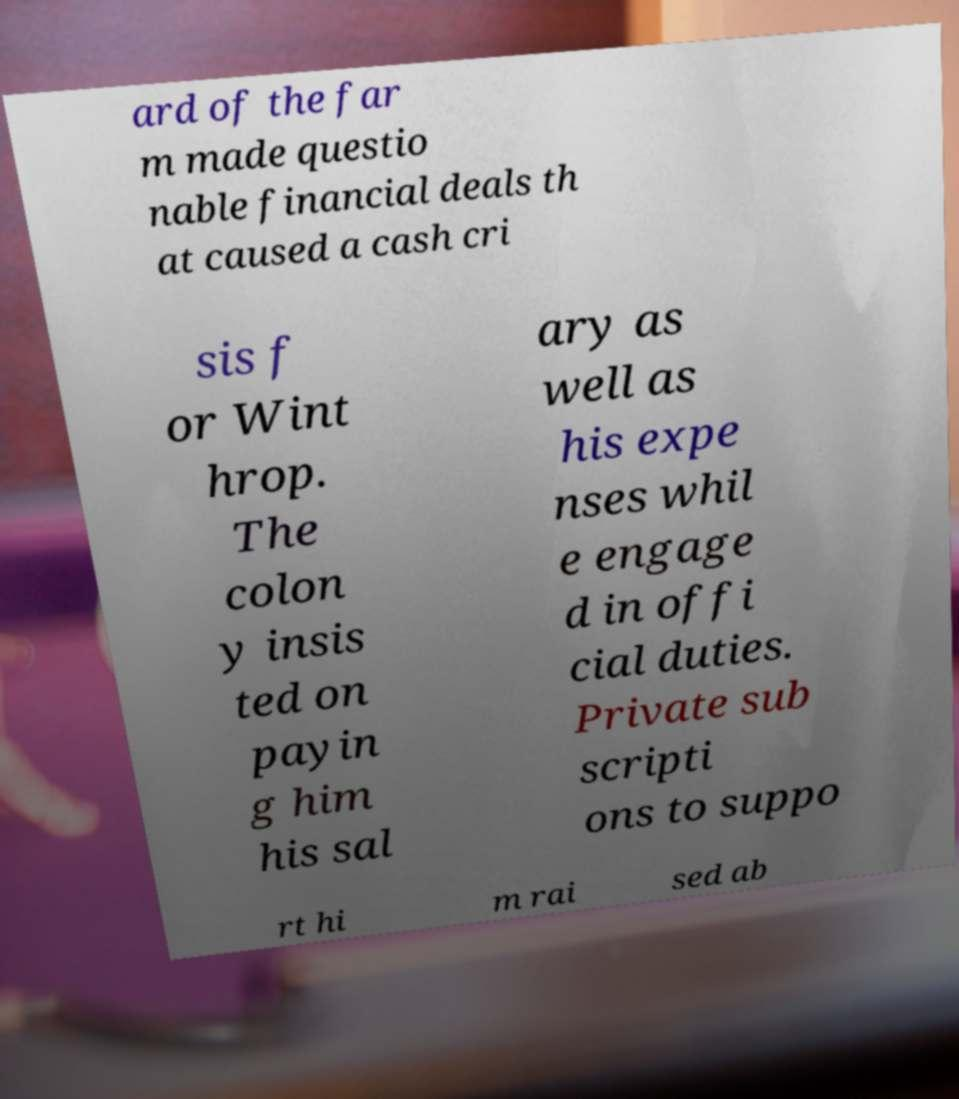Can you read and provide the text displayed in the image?This photo seems to have some interesting text. Can you extract and type it out for me? ard of the far m made questio nable financial deals th at caused a cash cri sis f or Wint hrop. The colon y insis ted on payin g him his sal ary as well as his expe nses whil e engage d in offi cial duties. Private sub scripti ons to suppo rt hi m rai sed ab 